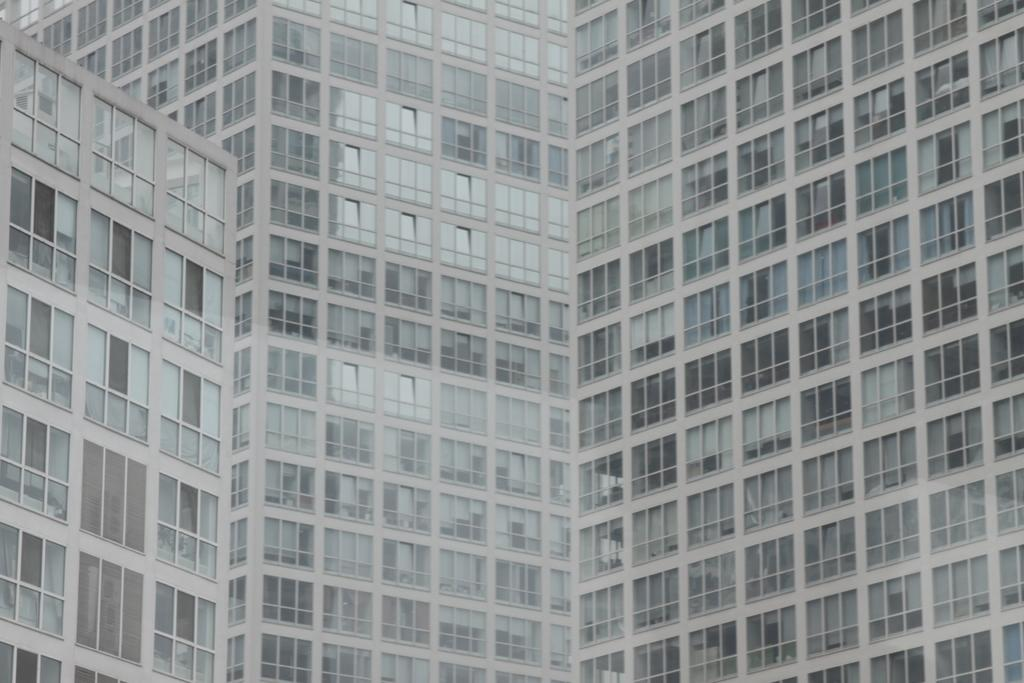What type of structure is visible in the image? There is a building in the image. What feature can be observed on the building? The building has multiple glass windows. What type of chin can be seen on the frog in the image? There is no frog or chin present in the image; it only features a building with multiple glass windows. 